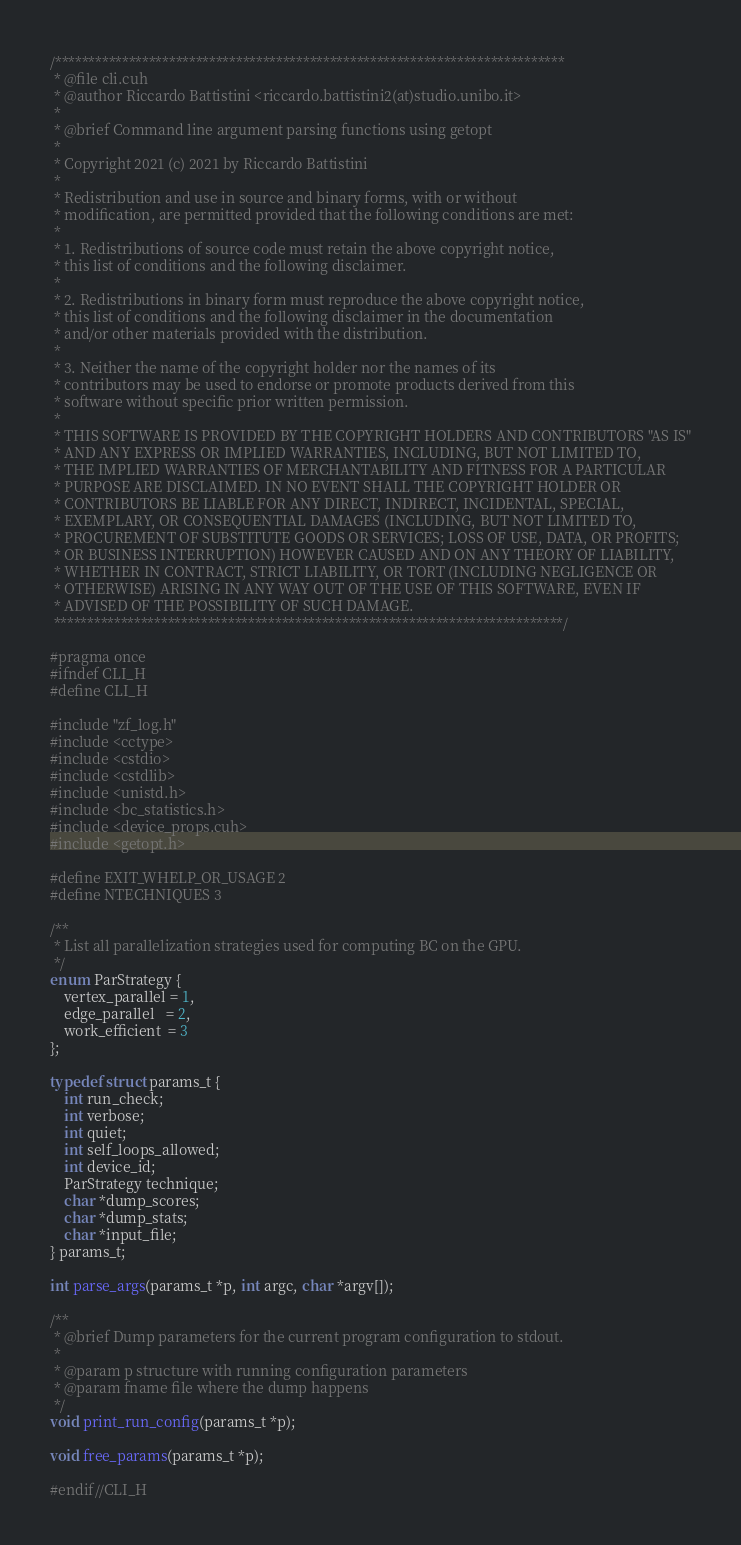<code> <loc_0><loc_0><loc_500><loc_500><_Cuda_>/****************************************************************************
 * @file cli.cuh
 * @author Riccardo Battistini <riccardo.battistini2(at)studio.unibo.it>
 *
 * @brief Command line argument parsing functions using getopt
 *
 * Copyright 2021 (c) 2021 by Riccardo Battistini
 *
 * Redistribution and use in source and binary forms, with or without
 * modification, are permitted provided that the following conditions are met:
 *
 * 1. Redistributions of source code must retain the above copyright notice,
 * this list of conditions and the following disclaimer.
 *
 * 2. Redistributions in binary form must reproduce the above copyright notice,
 * this list of conditions and the following disclaimer in the documentation
 * and/or other materials provided with the distribution.
 *
 * 3. Neither the name of the copyright holder nor the names of its
 * contributors may be used to endorse or promote products derived from this
 * software without specific prior written permission.
 *
 * THIS SOFTWARE IS PROVIDED BY THE COPYRIGHT HOLDERS AND CONTRIBUTORS "AS IS"
 * AND ANY EXPRESS OR IMPLIED WARRANTIES, INCLUDING, BUT NOT LIMITED TO,
 * THE IMPLIED WARRANTIES OF MERCHANTABILITY AND FITNESS FOR A PARTICULAR
 * PURPOSE ARE DISCLAIMED. IN NO EVENT SHALL THE COPYRIGHT HOLDER OR
 * CONTRIBUTORS BE LIABLE FOR ANY DIRECT, INDIRECT, INCIDENTAL, SPECIAL,
 * EXEMPLARY, OR CONSEQUENTIAL DAMAGES (INCLUDING, BUT NOT LIMITED TO,
 * PROCUREMENT OF SUBSTITUTE GOODS OR SERVICES; LOSS OF USE, DATA, OR PROFITS;
 * OR BUSINESS INTERRUPTION) HOWEVER CAUSED AND ON ANY THEORY OF LIABILITY,
 * WHETHER IN CONTRACT, STRICT LIABILITY, OR TORT (INCLUDING NEGLIGENCE OR
 * OTHERWISE) ARISING IN ANY WAY OUT OF THE USE OF THIS SOFTWARE, EVEN IF
 * ADVISED OF THE POSSIBILITY OF SUCH DAMAGE.
 ****************************************************************************/

#pragma once
#ifndef CLI_H
#define CLI_H

#include "zf_log.h"
#include <cctype>
#include <cstdio>
#include <cstdlib>
#include <unistd.h>
#include <bc_statistics.h>
#include <device_props.cuh>
#include <getopt.h>

#define EXIT_WHELP_OR_USAGE 2
#define NTECHNIQUES 3

/**
 * List all parallelization strategies used for computing BC on the GPU.
 */
enum ParStrategy {
    vertex_parallel = 1,
    edge_parallel   = 2,
    work_efficient  = 3
};

typedef struct params_t {
    int run_check;
    int verbose;
    int quiet;
    int self_loops_allowed;
    int device_id;
    ParStrategy technique;
    char *dump_scores;
    char *dump_stats;
    char *input_file;
} params_t;

int parse_args(params_t *p, int argc, char *argv[]);

/**
 * @brief Dump parameters for the current program configuration to stdout.
 *
 * @param p structure with running configuration parameters
 * @param fname file where the dump happens
 */
void print_run_config(params_t *p);

void free_params(params_t *p);

#endif//CLI_H
</code> 